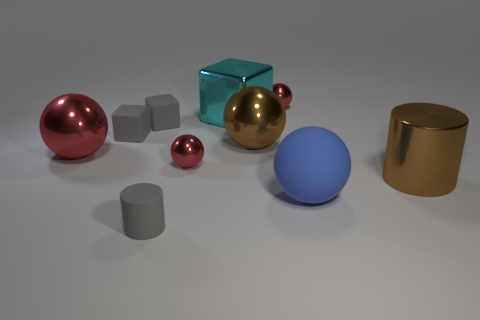What materials do the objects in the image seem to be made of? The objects in the image appear to have different materials. The spheres and the cylinder have a reflective surface suggesting they are made of some type of polished metal or plastic with metallic paint, while the matte cubes look like they could be made of a rougher material like stone or frosted glass. 